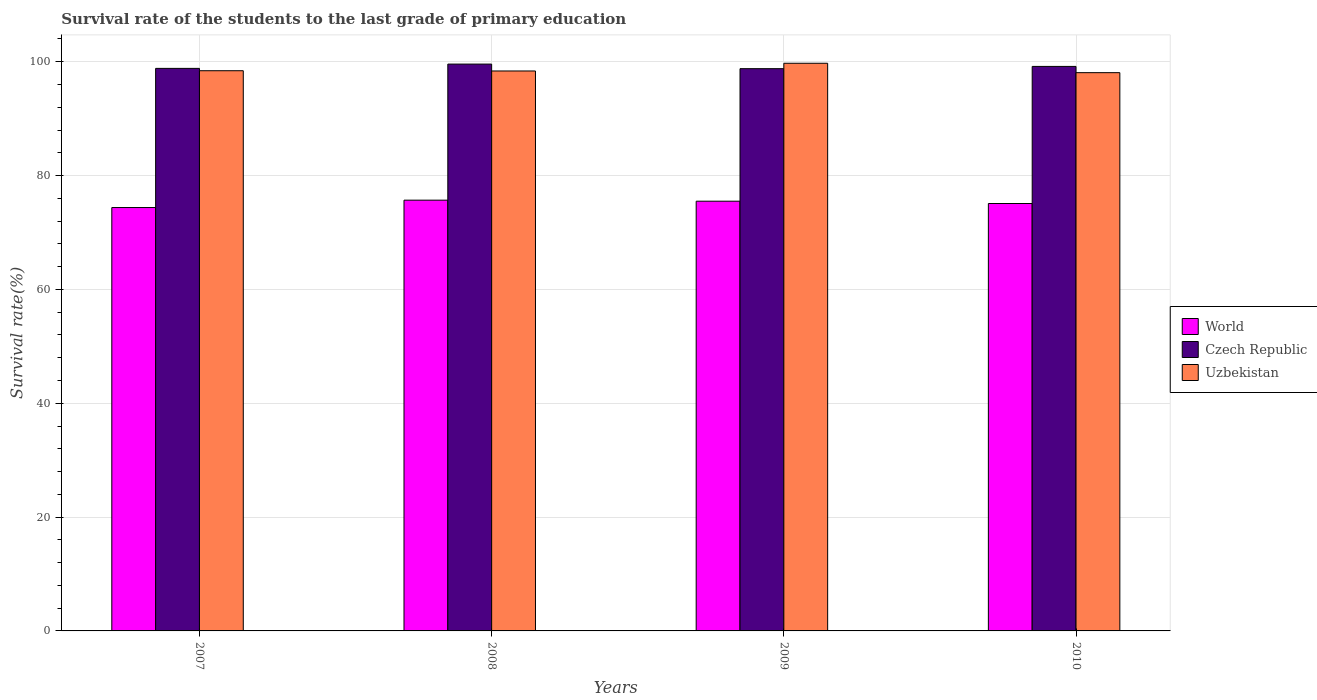How many different coloured bars are there?
Your response must be concise. 3. Are the number of bars per tick equal to the number of legend labels?
Make the answer very short. Yes. Are the number of bars on each tick of the X-axis equal?
Make the answer very short. Yes. How many bars are there on the 3rd tick from the left?
Give a very brief answer. 3. In how many cases, is the number of bars for a given year not equal to the number of legend labels?
Your answer should be very brief. 0. What is the survival rate of the students in World in 2010?
Give a very brief answer. 75.09. Across all years, what is the maximum survival rate of the students in Uzbekistan?
Keep it short and to the point. 99.73. Across all years, what is the minimum survival rate of the students in Uzbekistan?
Your response must be concise. 98.08. In which year was the survival rate of the students in Czech Republic minimum?
Your answer should be compact. 2009. What is the total survival rate of the students in Uzbekistan in the graph?
Your answer should be very brief. 394.6. What is the difference between the survival rate of the students in Czech Republic in 2007 and that in 2009?
Make the answer very short. 0.05. What is the difference between the survival rate of the students in World in 2007 and the survival rate of the students in Uzbekistan in 2009?
Make the answer very short. -25.35. What is the average survival rate of the students in Czech Republic per year?
Ensure brevity in your answer.  99.09. In the year 2008, what is the difference between the survival rate of the students in Czech Republic and survival rate of the students in Uzbekistan?
Ensure brevity in your answer.  1.21. In how many years, is the survival rate of the students in Uzbekistan greater than 64 %?
Ensure brevity in your answer.  4. What is the ratio of the survival rate of the students in Czech Republic in 2008 to that in 2009?
Offer a very short reply. 1.01. Is the difference between the survival rate of the students in Czech Republic in 2007 and 2010 greater than the difference between the survival rate of the students in Uzbekistan in 2007 and 2010?
Your answer should be compact. No. What is the difference between the highest and the second highest survival rate of the students in World?
Your answer should be very brief. 0.18. What is the difference between the highest and the lowest survival rate of the students in World?
Ensure brevity in your answer.  1.3. In how many years, is the survival rate of the students in Uzbekistan greater than the average survival rate of the students in Uzbekistan taken over all years?
Provide a succinct answer. 1. What does the 3rd bar from the left in 2007 represents?
Provide a short and direct response. Uzbekistan. What does the 3rd bar from the right in 2010 represents?
Your answer should be compact. World. Are all the bars in the graph horizontal?
Your answer should be very brief. No. Where does the legend appear in the graph?
Offer a terse response. Center right. What is the title of the graph?
Keep it short and to the point. Survival rate of the students to the last grade of primary education. Does "Nepal" appear as one of the legend labels in the graph?
Your response must be concise. No. What is the label or title of the Y-axis?
Make the answer very short. Survival rate(%). What is the Survival rate(%) of World in 2007?
Ensure brevity in your answer.  74.38. What is the Survival rate(%) in Czech Republic in 2007?
Your answer should be compact. 98.83. What is the Survival rate(%) of Uzbekistan in 2007?
Your answer should be very brief. 98.42. What is the Survival rate(%) of World in 2008?
Keep it short and to the point. 75.68. What is the Survival rate(%) of Czech Republic in 2008?
Offer a terse response. 99.58. What is the Survival rate(%) of Uzbekistan in 2008?
Make the answer very short. 98.37. What is the Survival rate(%) in World in 2009?
Provide a short and direct response. 75.5. What is the Survival rate(%) in Czech Republic in 2009?
Your answer should be compact. 98.78. What is the Survival rate(%) of Uzbekistan in 2009?
Your answer should be very brief. 99.73. What is the Survival rate(%) in World in 2010?
Ensure brevity in your answer.  75.09. What is the Survival rate(%) of Czech Republic in 2010?
Offer a terse response. 99.18. What is the Survival rate(%) of Uzbekistan in 2010?
Your answer should be compact. 98.08. Across all years, what is the maximum Survival rate(%) in World?
Provide a short and direct response. 75.68. Across all years, what is the maximum Survival rate(%) of Czech Republic?
Provide a succinct answer. 99.58. Across all years, what is the maximum Survival rate(%) in Uzbekistan?
Your answer should be compact. 99.73. Across all years, what is the minimum Survival rate(%) in World?
Your answer should be compact. 74.38. Across all years, what is the minimum Survival rate(%) of Czech Republic?
Offer a terse response. 98.78. Across all years, what is the minimum Survival rate(%) of Uzbekistan?
Offer a very short reply. 98.08. What is the total Survival rate(%) of World in the graph?
Make the answer very short. 300.65. What is the total Survival rate(%) of Czech Republic in the graph?
Ensure brevity in your answer.  396.37. What is the total Survival rate(%) in Uzbekistan in the graph?
Provide a short and direct response. 394.6. What is the difference between the Survival rate(%) in World in 2007 and that in 2008?
Provide a succinct answer. -1.3. What is the difference between the Survival rate(%) of Czech Republic in 2007 and that in 2008?
Provide a short and direct response. -0.75. What is the difference between the Survival rate(%) of Uzbekistan in 2007 and that in 2008?
Ensure brevity in your answer.  0.04. What is the difference between the Survival rate(%) in World in 2007 and that in 2009?
Ensure brevity in your answer.  -1.11. What is the difference between the Survival rate(%) in Czech Republic in 2007 and that in 2009?
Make the answer very short. 0.05. What is the difference between the Survival rate(%) of Uzbekistan in 2007 and that in 2009?
Give a very brief answer. -1.31. What is the difference between the Survival rate(%) in World in 2007 and that in 2010?
Offer a terse response. -0.71. What is the difference between the Survival rate(%) in Czech Republic in 2007 and that in 2010?
Your response must be concise. -0.35. What is the difference between the Survival rate(%) of Uzbekistan in 2007 and that in 2010?
Make the answer very short. 0.34. What is the difference between the Survival rate(%) of World in 2008 and that in 2009?
Your answer should be compact. 0.18. What is the difference between the Survival rate(%) in Czech Republic in 2008 and that in 2009?
Your response must be concise. 0.8. What is the difference between the Survival rate(%) in Uzbekistan in 2008 and that in 2009?
Keep it short and to the point. -1.36. What is the difference between the Survival rate(%) of World in 2008 and that in 2010?
Your answer should be compact. 0.59. What is the difference between the Survival rate(%) in Czech Republic in 2008 and that in 2010?
Your answer should be very brief. 0.41. What is the difference between the Survival rate(%) of Uzbekistan in 2008 and that in 2010?
Ensure brevity in your answer.  0.3. What is the difference between the Survival rate(%) in World in 2009 and that in 2010?
Offer a very short reply. 0.41. What is the difference between the Survival rate(%) of Czech Republic in 2009 and that in 2010?
Ensure brevity in your answer.  -0.4. What is the difference between the Survival rate(%) of Uzbekistan in 2009 and that in 2010?
Offer a terse response. 1.65. What is the difference between the Survival rate(%) in World in 2007 and the Survival rate(%) in Czech Republic in 2008?
Ensure brevity in your answer.  -25.2. What is the difference between the Survival rate(%) in World in 2007 and the Survival rate(%) in Uzbekistan in 2008?
Ensure brevity in your answer.  -23.99. What is the difference between the Survival rate(%) in Czech Republic in 2007 and the Survival rate(%) in Uzbekistan in 2008?
Give a very brief answer. 0.46. What is the difference between the Survival rate(%) of World in 2007 and the Survival rate(%) of Czech Republic in 2009?
Your answer should be very brief. -24.4. What is the difference between the Survival rate(%) of World in 2007 and the Survival rate(%) of Uzbekistan in 2009?
Your response must be concise. -25.35. What is the difference between the Survival rate(%) in Czech Republic in 2007 and the Survival rate(%) in Uzbekistan in 2009?
Your answer should be very brief. -0.9. What is the difference between the Survival rate(%) in World in 2007 and the Survival rate(%) in Czech Republic in 2010?
Make the answer very short. -24.79. What is the difference between the Survival rate(%) of World in 2007 and the Survival rate(%) of Uzbekistan in 2010?
Provide a succinct answer. -23.7. What is the difference between the Survival rate(%) of Czech Republic in 2007 and the Survival rate(%) of Uzbekistan in 2010?
Ensure brevity in your answer.  0.75. What is the difference between the Survival rate(%) of World in 2008 and the Survival rate(%) of Czech Republic in 2009?
Provide a succinct answer. -23.1. What is the difference between the Survival rate(%) of World in 2008 and the Survival rate(%) of Uzbekistan in 2009?
Keep it short and to the point. -24.05. What is the difference between the Survival rate(%) in Czech Republic in 2008 and the Survival rate(%) in Uzbekistan in 2009?
Your answer should be compact. -0.15. What is the difference between the Survival rate(%) of World in 2008 and the Survival rate(%) of Czech Republic in 2010?
Offer a very short reply. -23.5. What is the difference between the Survival rate(%) of World in 2008 and the Survival rate(%) of Uzbekistan in 2010?
Your response must be concise. -22.4. What is the difference between the Survival rate(%) of Czech Republic in 2008 and the Survival rate(%) of Uzbekistan in 2010?
Keep it short and to the point. 1.51. What is the difference between the Survival rate(%) of World in 2009 and the Survival rate(%) of Czech Republic in 2010?
Offer a very short reply. -23.68. What is the difference between the Survival rate(%) of World in 2009 and the Survival rate(%) of Uzbekistan in 2010?
Ensure brevity in your answer.  -22.58. What is the difference between the Survival rate(%) of Czech Republic in 2009 and the Survival rate(%) of Uzbekistan in 2010?
Ensure brevity in your answer.  0.7. What is the average Survival rate(%) in World per year?
Your answer should be compact. 75.16. What is the average Survival rate(%) in Czech Republic per year?
Keep it short and to the point. 99.09. What is the average Survival rate(%) of Uzbekistan per year?
Keep it short and to the point. 98.65. In the year 2007, what is the difference between the Survival rate(%) of World and Survival rate(%) of Czech Republic?
Your response must be concise. -24.45. In the year 2007, what is the difference between the Survival rate(%) of World and Survival rate(%) of Uzbekistan?
Your answer should be compact. -24.04. In the year 2007, what is the difference between the Survival rate(%) in Czech Republic and Survival rate(%) in Uzbekistan?
Provide a short and direct response. 0.41. In the year 2008, what is the difference between the Survival rate(%) in World and Survival rate(%) in Czech Republic?
Offer a very short reply. -23.91. In the year 2008, what is the difference between the Survival rate(%) in World and Survival rate(%) in Uzbekistan?
Offer a terse response. -22.7. In the year 2008, what is the difference between the Survival rate(%) in Czech Republic and Survival rate(%) in Uzbekistan?
Your answer should be compact. 1.21. In the year 2009, what is the difference between the Survival rate(%) in World and Survival rate(%) in Czech Republic?
Give a very brief answer. -23.28. In the year 2009, what is the difference between the Survival rate(%) in World and Survival rate(%) in Uzbekistan?
Provide a succinct answer. -24.23. In the year 2009, what is the difference between the Survival rate(%) in Czech Republic and Survival rate(%) in Uzbekistan?
Provide a succinct answer. -0.95. In the year 2010, what is the difference between the Survival rate(%) of World and Survival rate(%) of Czech Republic?
Ensure brevity in your answer.  -24.09. In the year 2010, what is the difference between the Survival rate(%) in World and Survival rate(%) in Uzbekistan?
Your answer should be very brief. -22.99. In the year 2010, what is the difference between the Survival rate(%) of Czech Republic and Survival rate(%) of Uzbekistan?
Give a very brief answer. 1.1. What is the ratio of the Survival rate(%) in World in 2007 to that in 2008?
Provide a succinct answer. 0.98. What is the ratio of the Survival rate(%) in World in 2007 to that in 2009?
Your answer should be compact. 0.99. What is the ratio of the Survival rate(%) in Czech Republic in 2007 to that in 2009?
Your response must be concise. 1. What is the ratio of the Survival rate(%) in World in 2007 to that in 2010?
Your answer should be very brief. 0.99. What is the ratio of the Survival rate(%) of Czech Republic in 2008 to that in 2009?
Ensure brevity in your answer.  1.01. What is the ratio of the Survival rate(%) in Uzbekistan in 2008 to that in 2009?
Offer a terse response. 0.99. What is the ratio of the Survival rate(%) in World in 2008 to that in 2010?
Give a very brief answer. 1.01. What is the ratio of the Survival rate(%) of Czech Republic in 2008 to that in 2010?
Ensure brevity in your answer.  1. What is the ratio of the Survival rate(%) in Uzbekistan in 2008 to that in 2010?
Provide a succinct answer. 1. What is the ratio of the Survival rate(%) in World in 2009 to that in 2010?
Provide a short and direct response. 1.01. What is the ratio of the Survival rate(%) of Uzbekistan in 2009 to that in 2010?
Your answer should be compact. 1.02. What is the difference between the highest and the second highest Survival rate(%) in World?
Your answer should be very brief. 0.18. What is the difference between the highest and the second highest Survival rate(%) in Czech Republic?
Provide a short and direct response. 0.41. What is the difference between the highest and the second highest Survival rate(%) of Uzbekistan?
Give a very brief answer. 1.31. What is the difference between the highest and the lowest Survival rate(%) of World?
Your response must be concise. 1.3. What is the difference between the highest and the lowest Survival rate(%) in Czech Republic?
Your answer should be compact. 0.8. What is the difference between the highest and the lowest Survival rate(%) in Uzbekistan?
Your answer should be very brief. 1.65. 